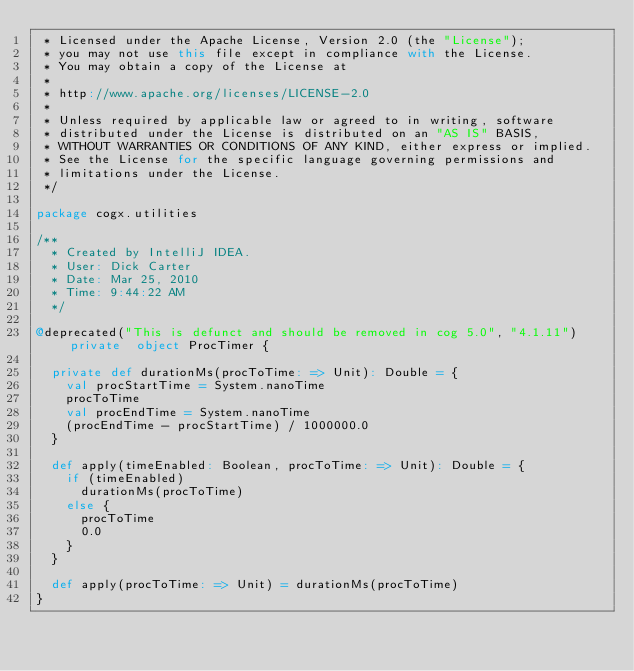Convert code to text. <code><loc_0><loc_0><loc_500><loc_500><_Scala_> * Licensed under the Apache License, Version 2.0 (the "License");
 * you may not use this file except in compliance with the License.
 * You may obtain a copy of the License at
 *
 * http://www.apache.org/licenses/LICENSE-2.0
 *
 * Unless required by applicable law or agreed to in writing, software
 * distributed under the License is distributed on an "AS IS" BASIS,
 * WITHOUT WARRANTIES OR CONDITIONS OF ANY KIND, either express or implied.
 * See the License for the specific language governing permissions and
 * limitations under the License.
 */

package cogx.utilities

/**
  * Created by IntelliJ IDEA.
  * User: Dick Carter
  * Date: Mar 25, 2010
  * Time: 9:44:22 AM
  */

@deprecated("This is defunct and should be removed in cog 5.0", "4.1.11") private  object ProcTimer {

  private def durationMs(procToTime: => Unit): Double = {
    val procStartTime = System.nanoTime
    procToTime
    val procEndTime = System.nanoTime
    (procEndTime - procStartTime) / 1000000.0
  }

  def apply(timeEnabled: Boolean, procToTime: => Unit): Double = {
    if (timeEnabled)
      durationMs(procToTime)
    else {
      procToTime
      0.0
    }
  }

  def apply(procToTime: => Unit) = durationMs(procToTime)
}</code> 